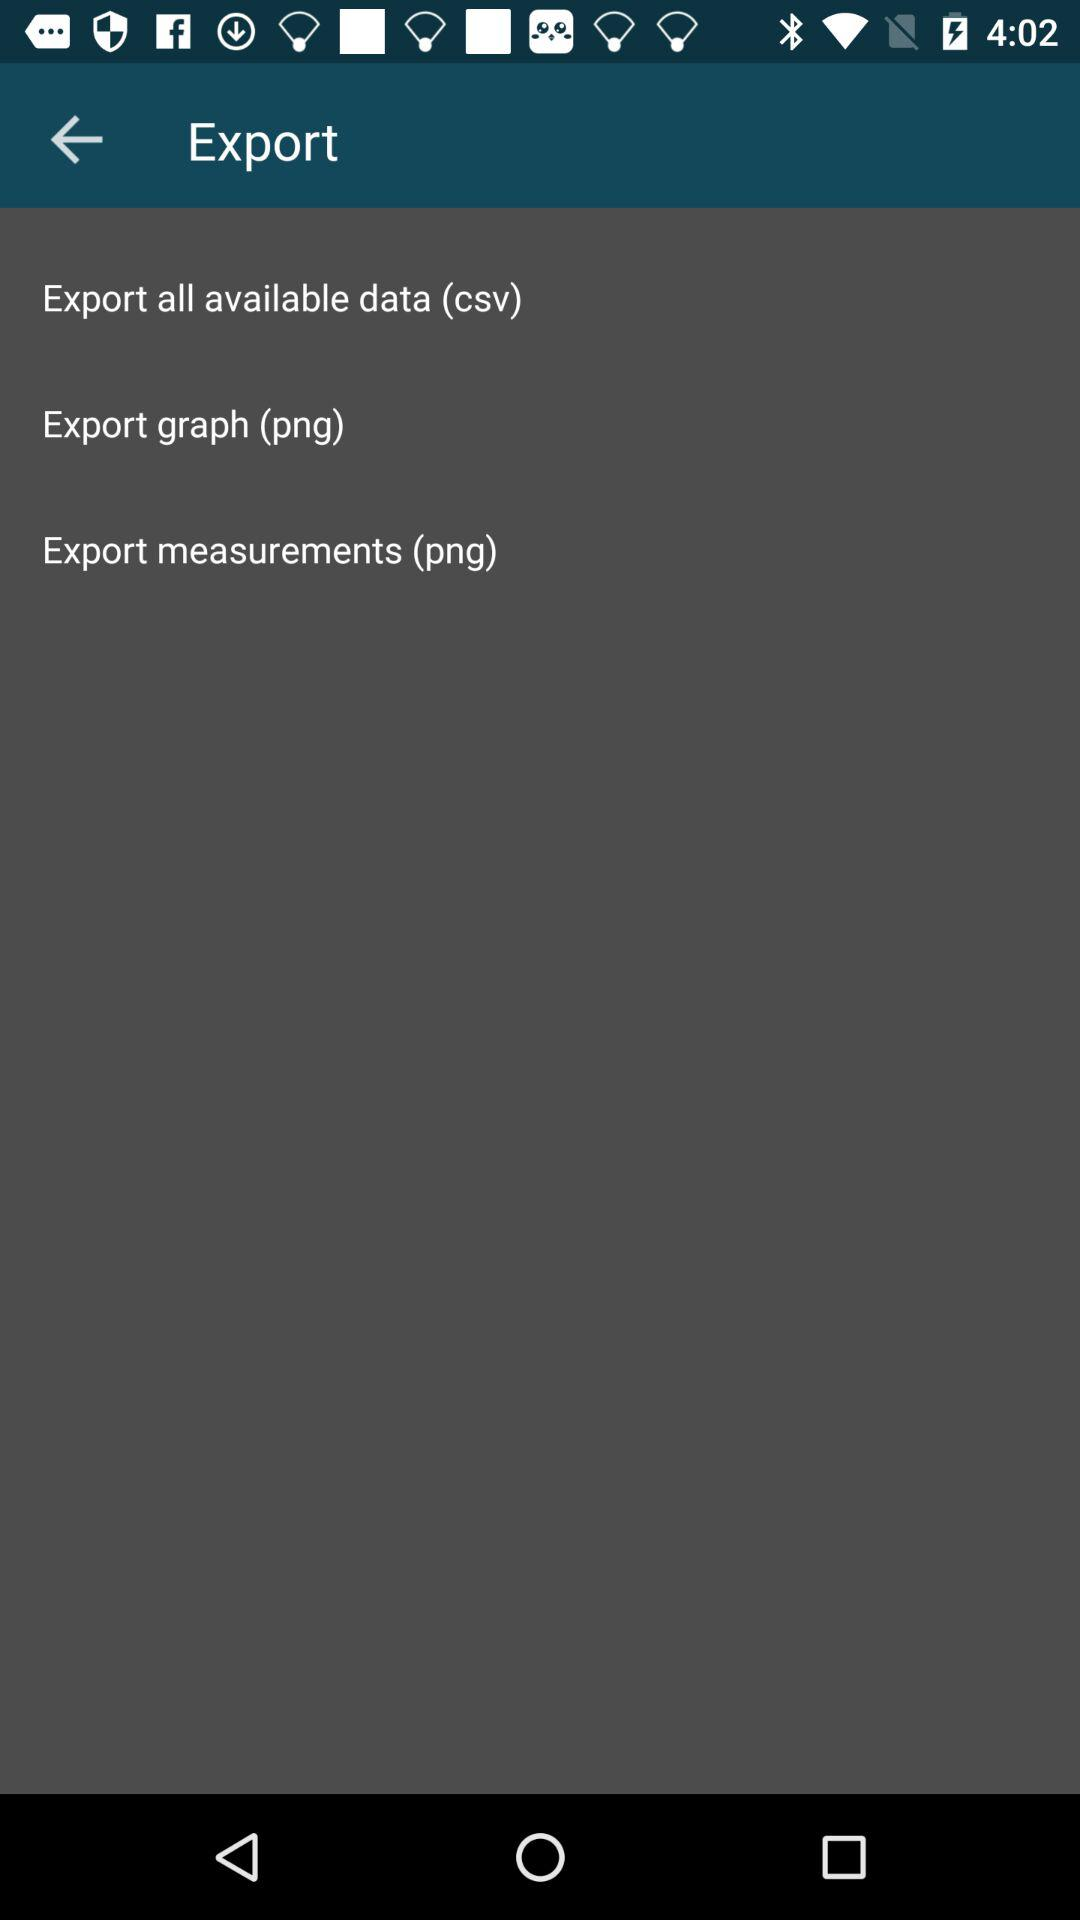How many export options are there?
Answer the question using a single word or phrase. 3 